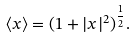Convert formula to latex. <formula><loc_0><loc_0><loc_500><loc_500>\langle x \rangle = ( 1 + | x | ^ { 2 } ) ^ { \frac { 1 } { 2 } } .</formula> 